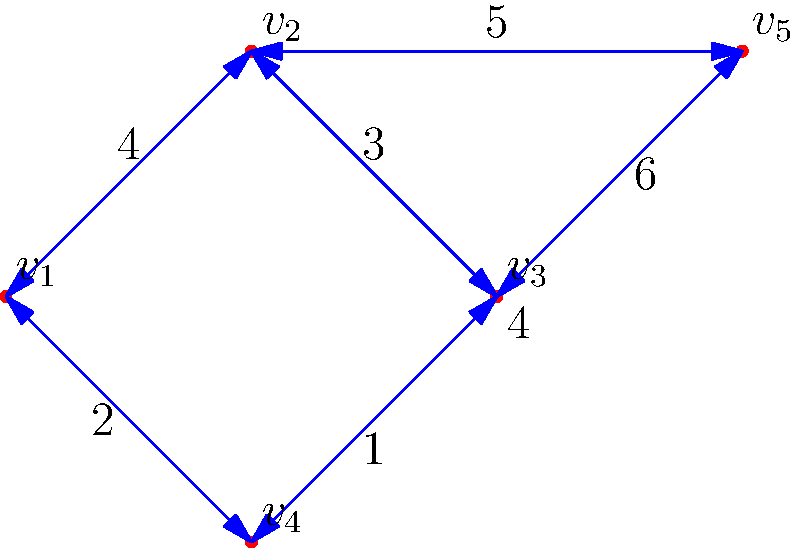In the given weighted graph, find the minimum spanning tree using Kruskal's algorithm. What is the total weight of the minimum spanning tree? Let's apply Kruskal's algorithm step by step:

1. Sort all edges by weight in ascending order:
   $(v_3, v_4)$ : 1
   $(v_1, v_4)$ : 2
   $(v_2, v_3)$ : 3
   $(v_1, v_2)$ : 4
   $(v_4, v_5)$ : 4
   $(v_2, v_5)$ : 5
   $(v_3, v_5)$ : 6

2. Start with an empty set of edges and add edges that don't create cycles:
   - Add $(v_3, v_4)$ : weight 1
   - Add $(v_1, v_4)$ : weight 2
   - Add $(v_2, v_3)$ : weight 3
   - Add $(v_2, v_5)$ : weight 5

3. We now have a minimum spanning tree with 4 edges (for 5 vertices).

4. Calculate the total weight:
   $1 + 2 + 3 + 5 = 11$

Therefore, the total weight of the minimum spanning tree is 11.
Answer: 11 